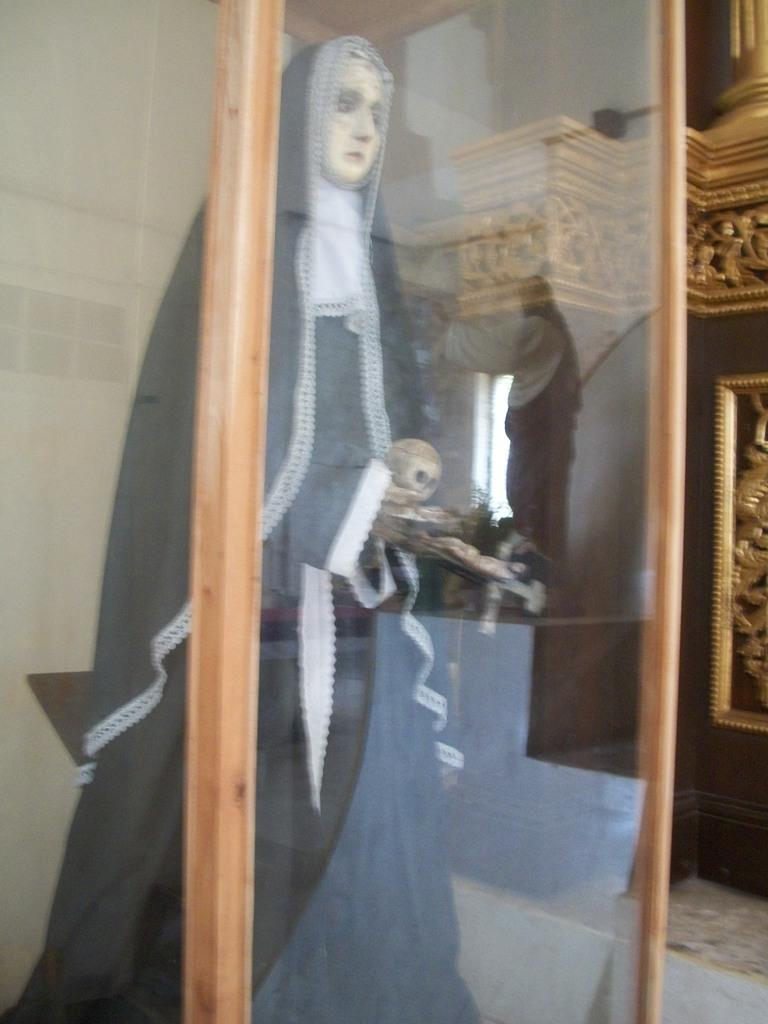What is located in the foreground of the image? There is a glass case in the foreground of the image. What can be seen inside the glass case? There is a sculpture inside the glass case. What type of sculptures are on the right side of the image? There are wooden sculptures on the right side of the image. What architectural features can be seen in the image? There is a window and a wall in the image. What type of pump is visible in the image? There is no pump present in the image. What type of skirt is worn by the sculpture in the glass case? The sculpture in the glass case is not a person and does not wear a skirt. 